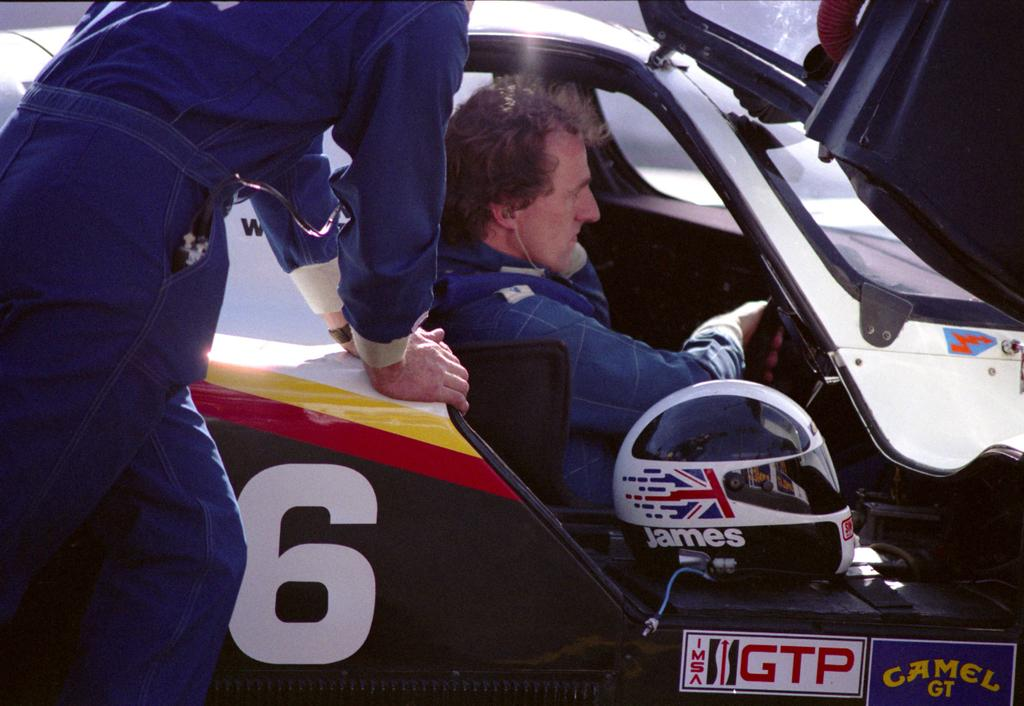What is the main subject of the image? The main subject of the image is a car. Who or what is inside the car? A man is sitting in the car. Can you describe the person standing near the car? There is a person standing on the left side of the car. What safety gear is visible in the image? A helmet is visible in the front of the image. What type of linen is being used to cover the car in the image? There is no linen present in the image, and the car is not covered. What experience does the person standing near the car have with driving? The image does not provide any information about the person's experience with driving. 